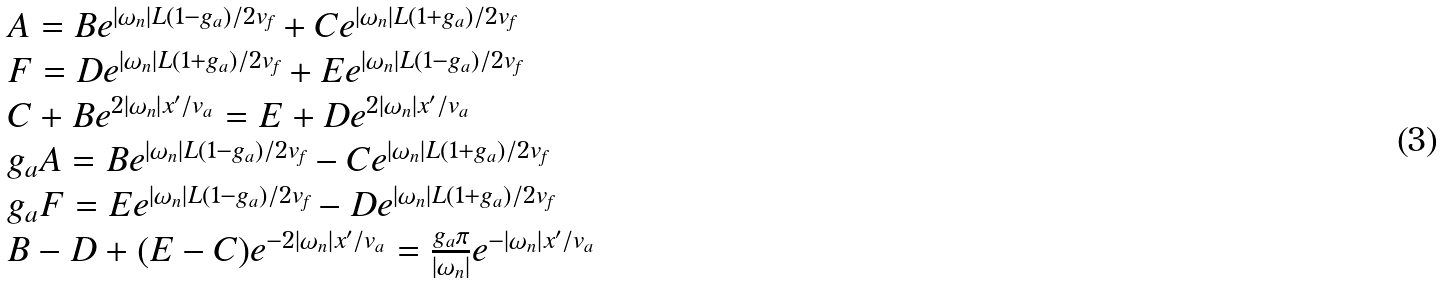Convert formula to latex. <formula><loc_0><loc_0><loc_500><loc_500>\begin{array} { l } A = B e ^ { | \omega _ { n } | L ( 1 - g _ { a } ) / 2 v _ { \text {f} } } + C e ^ { | \omega _ { n } | L ( 1 + g _ { a } ) / 2 v _ { \text {f} } } \\ F = D e ^ { | \omega _ { n } | L ( 1 + g _ { a } ) / 2 v _ { \text {f} } } + E e ^ { | \omega _ { n } | L ( 1 - g _ { a } ) / 2 v _ { \text {f} } } \\ C + B e ^ { 2 | \omega _ { n } | x ^ { \prime } / v _ { a } } = E + D e ^ { 2 | \omega _ { n } | x ^ { \prime } / v _ { a } } \\ g _ { a } A = B e ^ { | \omega _ { n } | L ( 1 - g _ { a } ) / 2 v _ { \text {f} } } - C e ^ { | \omega _ { n } | L ( 1 + g _ { a } ) / 2 v _ { \text {f} } } \\ g _ { a } F = E e ^ { | \omega _ { n } | L ( 1 - g _ { a } ) / 2 v _ { \text {f} } } - D e ^ { | \omega _ { n } | L ( 1 + g _ { a } ) / 2 v _ { \text {f} } } \\ B - D + ( E - C ) e ^ { - 2 | \omega _ { n } | x ^ { \prime } / v _ { a } } = \frac { g _ { a } \pi } { | \omega _ { n } | } e ^ { - | \omega _ { n } | x ^ { \prime } / v _ { a } } \\ \end{array}</formula> 